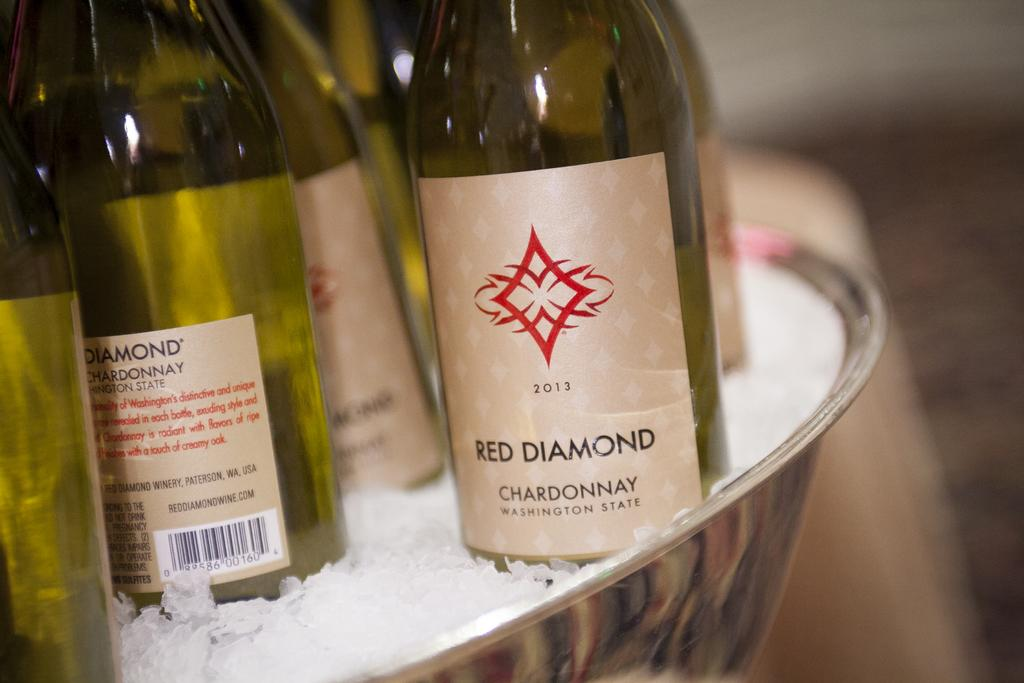What is in the bowl that is visible in the image? There are liquor bottles and ice in the bowl. Where might this image have been taken? The image might have been taken in a hotel. What type of agreement is being signed in the image? There is no agreement or signing activity present in the image; it features a bowl with liquor bottles and ice. Can you see a receipt for the liquor bottles in the image? There is no receipt visible in the image. 